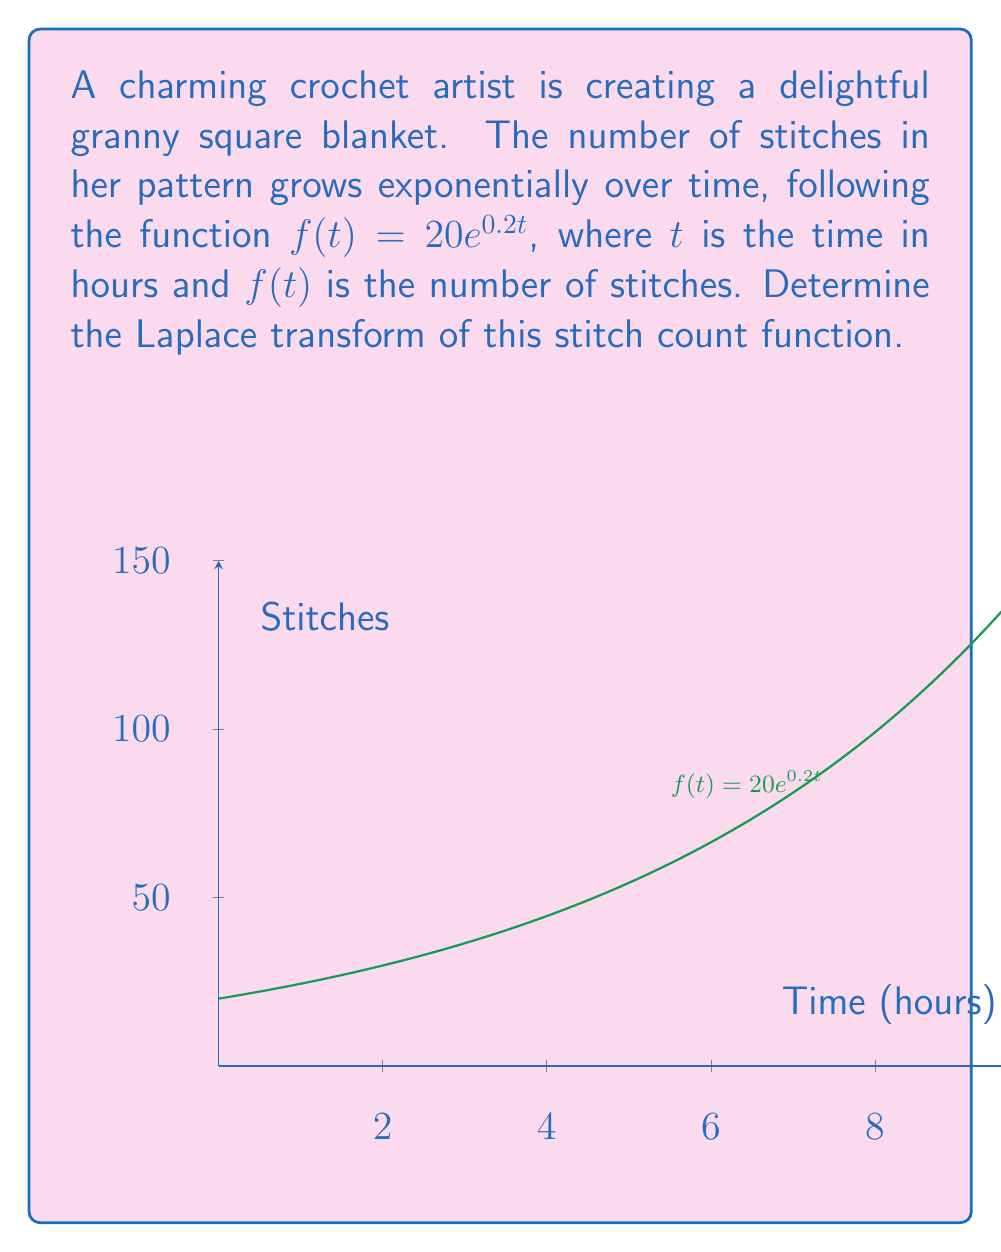Provide a solution to this math problem. To find the Laplace transform of $f(t) = 20e^{0.2t}$, we'll follow these steps:

1) The Laplace transform of $e^{at}$ is given by the formula:
   $$\mathcal{L}\{e^{at}\} = \frac{1}{s-a}$$

2) In our case, $a = 0.2$ and we have a constant factor of 20. We can use the linearity property of Laplace transforms:
   $$\mathcal{L}\{20e^{0.2t}\} = 20\mathcal{L}\{e^{0.2t}\}$$

3) Applying the formula from step 1:
   $$20\mathcal{L}\{e^{0.2t}\} = 20 \cdot \frac{1}{s-0.2}$$

4) Simplifying:
   $$\mathcal{L}\{f(t)\} = \frac{20}{s-0.2}$$

This is the Laplace transform of our stitch count function.
Answer: $$\frac{20}{s-0.2}$$ 